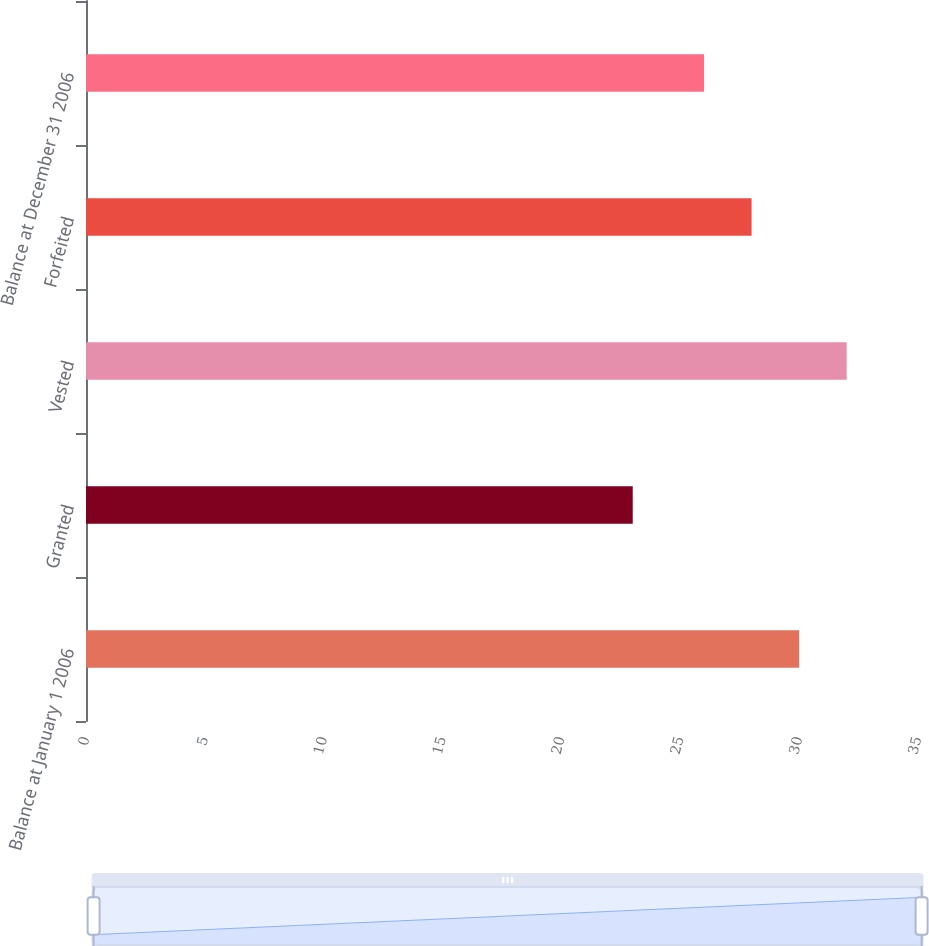Convert chart. <chart><loc_0><loc_0><loc_500><loc_500><bar_chart><fcel>Balance at January 1 2006<fcel>Granted<fcel>Vested<fcel>Forfeited<fcel>Balance at December 31 2006<nl><fcel>30<fcel>23<fcel>32<fcel>28<fcel>26<nl></chart> 